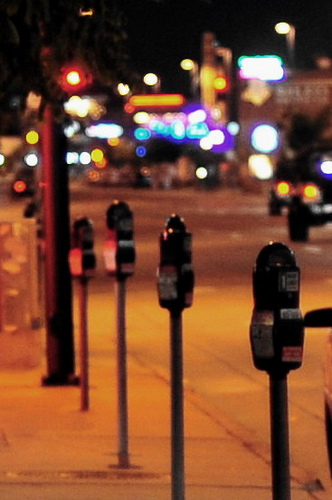<image>How much debris and litter is on the sidewalk? I don't know if there is any debris and litter on the sidewalk, but it seems to be none or minimal. How much debris and litter is on the sidewalk? There is no debris and litter on the sidewalk. It is clean. 